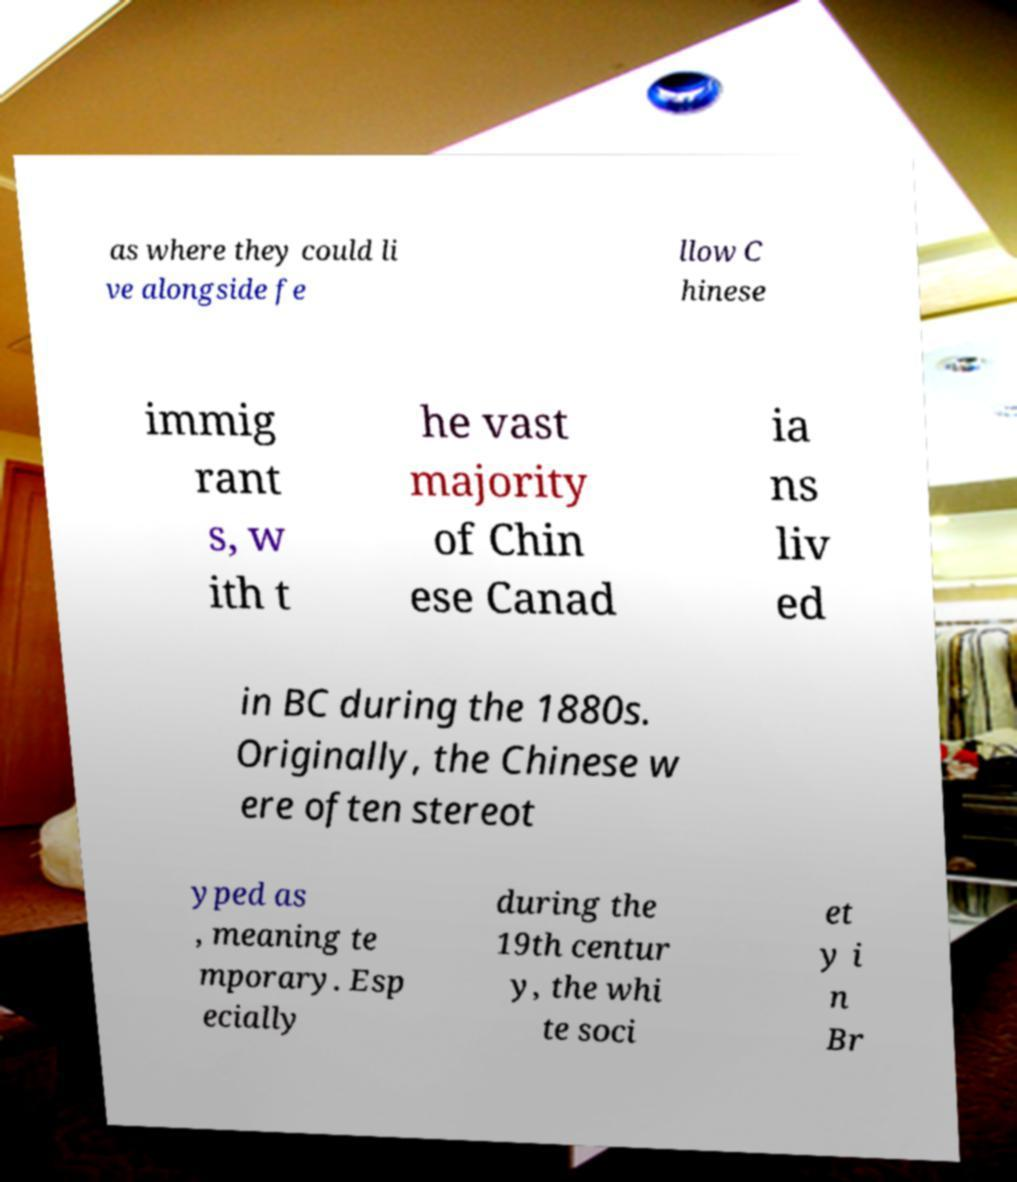What messages or text are displayed in this image? I need them in a readable, typed format. as where they could li ve alongside fe llow C hinese immig rant s, w ith t he vast majority of Chin ese Canad ia ns liv ed in BC during the 1880s. Originally, the Chinese w ere often stereot yped as , meaning te mporary. Esp ecially during the 19th centur y, the whi te soci et y i n Br 